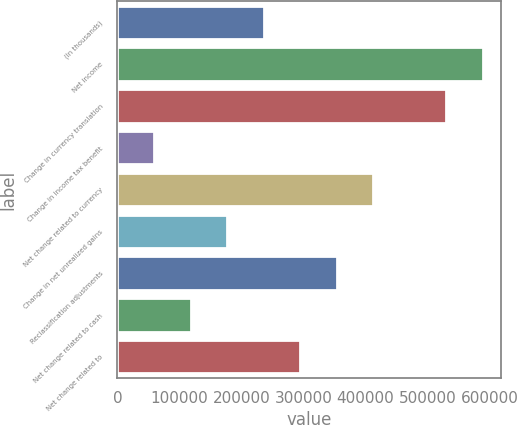<chart> <loc_0><loc_0><loc_500><loc_500><bar_chart><fcel>(In thousands)<fcel>Net income<fcel>Change in currency translation<fcel>Change in income tax benefit<fcel>Net change related to currency<fcel>Change in net unrealized gains<fcel>Reclassification adjustments<fcel>Net change related to cash<fcel>Net change related to<nl><fcel>236022<fcel>589130<fcel>530279<fcel>59468.3<fcel>412576<fcel>177171<fcel>353725<fcel>118320<fcel>294874<nl></chart> 